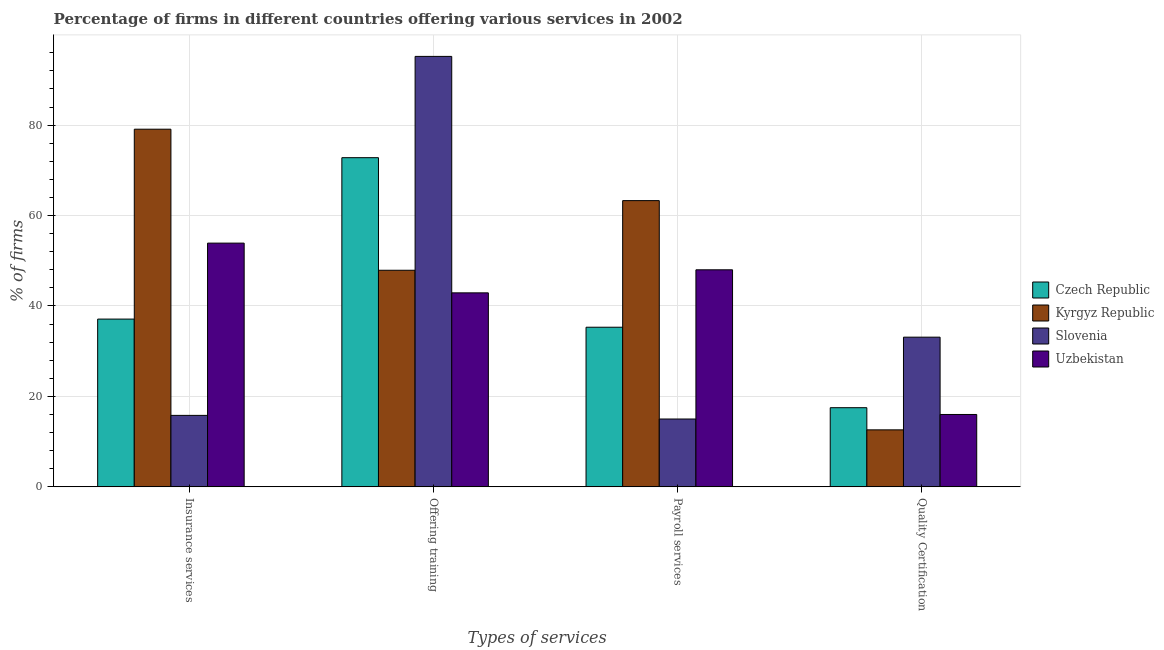How many different coloured bars are there?
Provide a short and direct response. 4. How many bars are there on the 1st tick from the left?
Your response must be concise. 4. What is the label of the 2nd group of bars from the left?
Make the answer very short. Offering training. What is the percentage of firms offering insurance services in Czech Republic?
Make the answer very short. 37.1. Across all countries, what is the maximum percentage of firms offering training?
Make the answer very short. 95.2. In which country was the percentage of firms offering insurance services maximum?
Provide a short and direct response. Kyrgyz Republic. In which country was the percentage of firms offering training minimum?
Offer a very short reply. Uzbekistan. What is the total percentage of firms offering insurance services in the graph?
Keep it short and to the point. 185.9. What is the difference between the percentage of firms offering payroll services in Czech Republic and that in Slovenia?
Keep it short and to the point. 20.3. What is the difference between the percentage of firms offering quality certification in Slovenia and the percentage of firms offering insurance services in Czech Republic?
Your response must be concise. -4. What is the average percentage of firms offering insurance services per country?
Your answer should be very brief. 46.48. What is the difference between the percentage of firms offering training and percentage of firms offering payroll services in Slovenia?
Your response must be concise. 80.2. What is the ratio of the percentage of firms offering quality certification in Kyrgyz Republic to that in Uzbekistan?
Keep it short and to the point. 0.79. Is the difference between the percentage of firms offering payroll services in Kyrgyz Republic and Czech Republic greater than the difference between the percentage of firms offering insurance services in Kyrgyz Republic and Czech Republic?
Provide a succinct answer. No. What is the difference between the highest and the second highest percentage of firms offering payroll services?
Your answer should be very brief. 15.3. What is the difference between the highest and the lowest percentage of firms offering training?
Your answer should be very brief. 52.3. In how many countries, is the percentage of firms offering quality certification greater than the average percentage of firms offering quality certification taken over all countries?
Your response must be concise. 1. Is it the case that in every country, the sum of the percentage of firms offering payroll services and percentage of firms offering training is greater than the sum of percentage of firms offering insurance services and percentage of firms offering quality certification?
Provide a short and direct response. No. What does the 1st bar from the left in Quality Certification represents?
Give a very brief answer. Czech Republic. What does the 1st bar from the right in Offering training represents?
Make the answer very short. Uzbekistan. How many bars are there?
Keep it short and to the point. 16. Are the values on the major ticks of Y-axis written in scientific E-notation?
Ensure brevity in your answer.  No. Does the graph contain any zero values?
Your response must be concise. No. Does the graph contain grids?
Your answer should be compact. Yes. How many legend labels are there?
Your answer should be very brief. 4. What is the title of the graph?
Your answer should be very brief. Percentage of firms in different countries offering various services in 2002. Does "Upper middle income" appear as one of the legend labels in the graph?
Keep it short and to the point. No. What is the label or title of the X-axis?
Provide a succinct answer. Types of services. What is the label or title of the Y-axis?
Your answer should be very brief. % of firms. What is the % of firms in Czech Republic in Insurance services?
Provide a succinct answer. 37.1. What is the % of firms of Kyrgyz Republic in Insurance services?
Offer a terse response. 79.1. What is the % of firms of Slovenia in Insurance services?
Your response must be concise. 15.8. What is the % of firms of Uzbekistan in Insurance services?
Provide a succinct answer. 53.9. What is the % of firms of Czech Republic in Offering training?
Provide a succinct answer. 72.8. What is the % of firms of Kyrgyz Republic in Offering training?
Offer a terse response. 47.9. What is the % of firms of Slovenia in Offering training?
Provide a succinct answer. 95.2. What is the % of firms of Uzbekistan in Offering training?
Provide a succinct answer. 42.9. What is the % of firms in Czech Republic in Payroll services?
Your answer should be compact. 35.3. What is the % of firms of Kyrgyz Republic in Payroll services?
Provide a short and direct response. 63.3. What is the % of firms of Slovenia in Payroll services?
Give a very brief answer. 15. What is the % of firms of Czech Republic in Quality Certification?
Ensure brevity in your answer.  17.5. What is the % of firms of Slovenia in Quality Certification?
Offer a terse response. 33.1. Across all Types of services, what is the maximum % of firms of Czech Republic?
Your answer should be very brief. 72.8. Across all Types of services, what is the maximum % of firms in Kyrgyz Republic?
Offer a terse response. 79.1. Across all Types of services, what is the maximum % of firms of Slovenia?
Give a very brief answer. 95.2. Across all Types of services, what is the maximum % of firms in Uzbekistan?
Your answer should be very brief. 53.9. Across all Types of services, what is the minimum % of firms of Kyrgyz Republic?
Ensure brevity in your answer.  12.6. Across all Types of services, what is the minimum % of firms in Slovenia?
Offer a terse response. 15. What is the total % of firms of Czech Republic in the graph?
Provide a succinct answer. 162.7. What is the total % of firms of Kyrgyz Republic in the graph?
Your response must be concise. 202.9. What is the total % of firms of Slovenia in the graph?
Offer a very short reply. 159.1. What is the total % of firms of Uzbekistan in the graph?
Keep it short and to the point. 160.8. What is the difference between the % of firms of Czech Republic in Insurance services and that in Offering training?
Offer a terse response. -35.7. What is the difference between the % of firms of Kyrgyz Republic in Insurance services and that in Offering training?
Ensure brevity in your answer.  31.2. What is the difference between the % of firms in Slovenia in Insurance services and that in Offering training?
Offer a terse response. -79.4. What is the difference between the % of firms of Slovenia in Insurance services and that in Payroll services?
Provide a succinct answer. 0.8. What is the difference between the % of firms of Czech Republic in Insurance services and that in Quality Certification?
Your answer should be compact. 19.6. What is the difference between the % of firms of Kyrgyz Republic in Insurance services and that in Quality Certification?
Provide a short and direct response. 66.5. What is the difference between the % of firms in Slovenia in Insurance services and that in Quality Certification?
Keep it short and to the point. -17.3. What is the difference between the % of firms in Uzbekistan in Insurance services and that in Quality Certification?
Your answer should be very brief. 37.9. What is the difference between the % of firms of Czech Republic in Offering training and that in Payroll services?
Offer a terse response. 37.5. What is the difference between the % of firms in Kyrgyz Republic in Offering training and that in Payroll services?
Your response must be concise. -15.4. What is the difference between the % of firms of Slovenia in Offering training and that in Payroll services?
Make the answer very short. 80.2. What is the difference between the % of firms of Uzbekistan in Offering training and that in Payroll services?
Offer a very short reply. -5.1. What is the difference between the % of firms in Czech Republic in Offering training and that in Quality Certification?
Your answer should be compact. 55.3. What is the difference between the % of firms in Kyrgyz Republic in Offering training and that in Quality Certification?
Offer a very short reply. 35.3. What is the difference between the % of firms of Slovenia in Offering training and that in Quality Certification?
Provide a succinct answer. 62.1. What is the difference between the % of firms in Uzbekistan in Offering training and that in Quality Certification?
Provide a succinct answer. 26.9. What is the difference between the % of firms of Czech Republic in Payroll services and that in Quality Certification?
Give a very brief answer. 17.8. What is the difference between the % of firms of Kyrgyz Republic in Payroll services and that in Quality Certification?
Offer a terse response. 50.7. What is the difference between the % of firms in Slovenia in Payroll services and that in Quality Certification?
Provide a succinct answer. -18.1. What is the difference between the % of firms in Uzbekistan in Payroll services and that in Quality Certification?
Offer a very short reply. 32. What is the difference between the % of firms of Czech Republic in Insurance services and the % of firms of Kyrgyz Republic in Offering training?
Provide a short and direct response. -10.8. What is the difference between the % of firms of Czech Republic in Insurance services and the % of firms of Slovenia in Offering training?
Keep it short and to the point. -58.1. What is the difference between the % of firms in Czech Republic in Insurance services and the % of firms in Uzbekistan in Offering training?
Ensure brevity in your answer.  -5.8. What is the difference between the % of firms in Kyrgyz Republic in Insurance services and the % of firms in Slovenia in Offering training?
Keep it short and to the point. -16.1. What is the difference between the % of firms of Kyrgyz Republic in Insurance services and the % of firms of Uzbekistan in Offering training?
Offer a terse response. 36.2. What is the difference between the % of firms of Slovenia in Insurance services and the % of firms of Uzbekistan in Offering training?
Offer a terse response. -27.1. What is the difference between the % of firms of Czech Republic in Insurance services and the % of firms of Kyrgyz Republic in Payroll services?
Ensure brevity in your answer.  -26.2. What is the difference between the % of firms of Czech Republic in Insurance services and the % of firms of Slovenia in Payroll services?
Give a very brief answer. 22.1. What is the difference between the % of firms of Czech Republic in Insurance services and the % of firms of Uzbekistan in Payroll services?
Make the answer very short. -10.9. What is the difference between the % of firms of Kyrgyz Republic in Insurance services and the % of firms of Slovenia in Payroll services?
Provide a succinct answer. 64.1. What is the difference between the % of firms of Kyrgyz Republic in Insurance services and the % of firms of Uzbekistan in Payroll services?
Make the answer very short. 31.1. What is the difference between the % of firms of Slovenia in Insurance services and the % of firms of Uzbekistan in Payroll services?
Ensure brevity in your answer.  -32.2. What is the difference between the % of firms in Czech Republic in Insurance services and the % of firms in Uzbekistan in Quality Certification?
Your answer should be compact. 21.1. What is the difference between the % of firms of Kyrgyz Republic in Insurance services and the % of firms of Uzbekistan in Quality Certification?
Offer a very short reply. 63.1. What is the difference between the % of firms of Czech Republic in Offering training and the % of firms of Slovenia in Payroll services?
Your answer should be very brief. 57.8. What is the difference between the % of firms in Czech Republic in Offering training and the % of firms in Uzbekistan in Payroll services?
Give a very brief answer. 24.8. What is the difference between the % of firms in Kyrgyz Republic in Offering training and the % of firms in Slovenia in Payroll services?
Your answer should be compact. 32.9. What is the difference between the % of firms of Kyrgyz Republic in Offering training and the % of firms of Uzbekistan in Payroll services?
Provide a short and direct response. -0.1. What is the difference between the % of firms in Slovenia in Offering training and the % of firms in Uzbekistan in Payroll services?
Offer a very short reply. 47.2. What is the difference between the % of firms in Czech Republic in Offering training and the % of firms in Kyrgyz Republic in Quality Certification?
Keep it short and to the point. 60.2. What is the difference between the % of firms of Czech Republic in Offering training and the % of firms of Slovenia in Quality Certification?
Your answer should be very brief. 39.7. What is the difference between the % of firms of Czech Republic in Offering training and the % of firms of Uzbekistan in Quality Certification?
Offer a very short reply. 56.8. What is the difference between the % of firms in Kyrgyz Republic in Offering training and the % of firms in Slovenia in Quality Certification?
Offer a terse response. 14.8. What is the difference between the % of firms of Kyrgyz Republic in Offering training and the % of firms of Uzbekistan in Quality Certification?
Your answer should be compact. 31.9. What is the difference between the % of firms in Slovenia in Offering training and the % of firms in Uzbekistan in Quality Certification?
Make the answer very short. 79.2. What is the difference between the % of firms in Czech Republic in Payroll services and the % of firms in Kyrgyz Republic in Quality Certification?
Ensure brevity in your answer.  22.7. What is the difference between the % of firms in Czech Republic in Payroll services and the % of firms in Uzbekistan in Quality Certification?
Keep it short and to the point. 19.3. What is the difference between the % of firms of Kyrgyz Republic in Payroll services and the % of firms of Slovenia in Quality Certification?
Keep it short and to the point. 30.2. What is the difference between the % of firms of Kyrgyz Republic in Payroll services and the % of firms of Uzbekistan in Quality Certification?
Offer a terse response. 47.3. What is the average % of firms of Czech Republic per Types of services?
Make the answer very short. 40.67. What is the average % of firms of Kyrgyz Republic per Types of services?
Provide a succinct answer. 50.73. What is the average % of firms of Slovenia per Types of services?
Provide a succinct answer. 39.77. What is the average % of firms in Uzbekistan per Types of services?
Keep it short and to the point. 40.2. What is the difference between the % of firms of Czech Republic and % of firms of Kyrgyz Republic in Insurance services?
Offer a terse response. -42. What is the difference between the % of firms of Czech Republic and % of firms of Slovenia in Insurance services?
Your response must be concise. 21.3. What is the difference between the % of firms in Czech Republic and % of firms in Uzbekistan in Insurance services?
Provide a short and direct response. -16.8. What is the difference between the % of firms of Kyrgyz Republic and % of firms of Slovenia in Insurance services?
Provide a succinct answer. 63.3. What is the difference between the % of firms of Kyrgyz Republic and % of firms of Uzbekistan in Insurance services?
Make the answer very short. 25.2. What is the difference between the % of firms in Slovenia and % of firms in Uzbekistan in Insurance services?
Give a very brief answer. -38.1. What is the difference between the % of firms in Czech Republic and % of firms in Kyrgyz Republic in Offering training?
Offer a terse response. 24.9. What is the difference between the % of firms in Czech Republic and % of firms in Slovenia in Offering training?
Offer a terse response. -22.4. What is the difference between the % of firms of Czech Republic and % of firms of Uzbekistan in Offering training?
Ensure brevity in your answer.  29.9. What is the difference between the % of firms in Kyrgyz Republic and % of firms in Slovenia in Offering training?
Keep it short and to the point. -47.3. What is the difference between the % of firms of Kyrgyz Republic and % of firms of Uzbekistan in Offering training?
Your response must be concise. 5. What is the difference between the % of firms of Slovenia and % of firms of Uzbekistan in Offering training?
Your response must be concise. 52.3. What is the difference between the % of firms of Czech Republic and % of firms of Kyrgyz Republic in Payroll services?
Provide a short and direct response. -28. What is the difference between the % of firms in Czech Republic and % of firms in Slovenia in Payroll services?
Your response must be concise. 20.3. What is the difference between the % of firms of Kyrgyz Republic and % of firms of Slovenia in Payroll services?
Your response must be concise. 48.3. What is the difference between the % of firms in Kyrgyz Republic and % of firms in Uzbekistan in Payroll services?
Make the answer very short. 15.3. What is the difference between the % of firms of Slovenia and % of firms of Uzbekistan in Payroll services?
Your answer should be very brief. -33. What is the difference between the % of firms in Czech Republic and % of firms in Kyrgyz Republic in Quality Certification?
Give a very brief answer. 4.9. What is the difference between the % of firms of Czech Republic and % of firms of Slovenia in Quality Certification?
Keep it short and to the point. -15.6. What is the difference between the % of firms of Kyrgyz Republic and % of firms of Slovenia in Quality Certification?
Keep it short and to the point. -20.5. What is the difference between the % of firms of Kyrgyz Republic and % of firms of Uzbekistan in Quality Certification?
Your answer should be very brief. -3.4. What is the ratio of the % of firms in Czech Republic in Insurance services to that in Offering training?
Your answer should be compact. 0.51. What is the ratio of the % of firms of Kyrgyz Republic in Insurance services to that in Offering training?
Give a very brief answer. 1.65. What is the ratio of the % of firms of Slovenia in Insurance services to that in Offering training?
Give a very brief answer. 0.17. What is the ratio of the % of firms in Uzbekistan in Insurance services to that in Offering training?
Your response must be concise. 1.26. What is the ratio of the % of firms in Czech Republic in Insurance services to that in Payroll services?
Keep it short and to the point. 1.05. What is the ratio of the % of firms of Kyrgyz Republic in Insurance services to that in Payroll services?
Keep it short and to the point. 1.25. What is the ratio of the % of firms of Slovenia in Insurance services to that in Payroll services?
Provide a short and direct response. 1.05. What is the ratio of the % of firms in Uzbekistan in Insurance services to that in Payroll services?
Your answer should be very brief. 1.12. What is the ratio of the % of firms in Czech Republic in Insurance services to that in Quality Certification?
Provide a succinct answer. 2.12. What is the ratio of the % of firms in Kyrgyz Republic in Insurance services to that in Quality Certification?
Provide a succinct answer. 6.28. What is the ratio of the % of firms in Slovenia in Insurance services to that in Quality Certification?
Your answer should be very brief. 0.48. What is the ratio of the % of firms of Uzbekistan in Insurance services to that in Quality Certification?
Provide a succinct answer. 3.37. What is the ratio of the % of firms of Czech Republic in Offering training to that in Payroll services?
Your response must be concise. 2.06. What is the ratio of the % of firms in Kyrgyz Republic in Offering training to that in Payroll services?
Provide a succinct answer. 0.76. What is the ratio of the % of firms in Slovenia in Offering training to that in Payroll services?
Offer a very short reply. 6.35. What is the ratio of the % of firms of Uzbekistan in Offering training to that in Payroll services?
Provide a succinct answer. 0.89. What is the ratio of the % of firms of Czech Republic in Offering training to that in Quality Certification?
Keep it short and to the point. 4.16. What is the ratio of the % of firms in Kyrgyz Republic in Offering training to that in Quality Certification?
Offer a terse response. 3.8. What is the ratio of the % of firms in Slovenia in Offering training to that in Quality Certification?
Ensure brevity in your answer.  2.88. What is the ratio of the % of firms of Uzbekistan in Offering training to that in Quality Certification?
Ensure brevity in your answer.  2.68. What is the ratio of the % of firms of Czech Republic in Payroll services to that in Quality Certification?
Provide a succinct answer. 2.02. What is the ratio of the % of firms of Kyrgyz Republic in Payroll services to that in Quality Certification?
Make the answer very short. 5.02. What is the ratio of the % of firms in Slovenia in Payroll services to that in Quality Certification?
Your answer should be very brief. 0.45. What is the ratio of the % of firms in Uzbekistan in Payroll services to that in Quality Certification?
Provide a succinct answer. 3. What is the difference between the highest and the second highest % of firms of Czech Republic?
Offer a very short reply. 35.7. What is the difference between the highest and the second highest % of firms in Slovenia?
Provide a succinct answer. 62.1. What is the difference between the highest and the second highest % of firms in Uzbekistan?
Provide a short and direct response. 5.9. What is the difference between the highest and the lowest % of firms of Czech Republic?
Your response must be concise. 55.3. What is the difference between the highest and the lowest % of firms in Kyrgyz Republic?
Your answer should be compact. 66.5. What is the difference between the highest and the lowest % of firms of Slovenia?
Provide a succinct answer. 80.2. What is the difference between the highest and the lowest % of firms in Uzbekistan?
Provide a succinct answer. 37.9. 